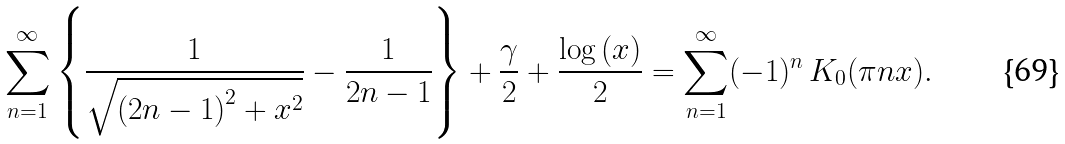<formula> <loc_0><loc_0><loc_500><loc_500>\sum _ { n = 1 } ^ { \infty } \left \{ \frac { 1 } { \sqrt { \left ( 2 n - 1 \right ) ^ { 2 } + x ^ { 2 } } } - \frac { 1 } { 2 n - 1 } \right \} + \frac { \gamma } { 2 } + \frac { \log \left ( x \right ) } { 2 } = \sum _ { n = 1 } ^ { \infty } ( - 1 ) ^ { n } \, K _ { 0 } ( \pi n x ) .</formula> 